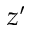<formula> <loc_0><loc_0><loc_500><loc_500>z ^ { \prime }</formula> 